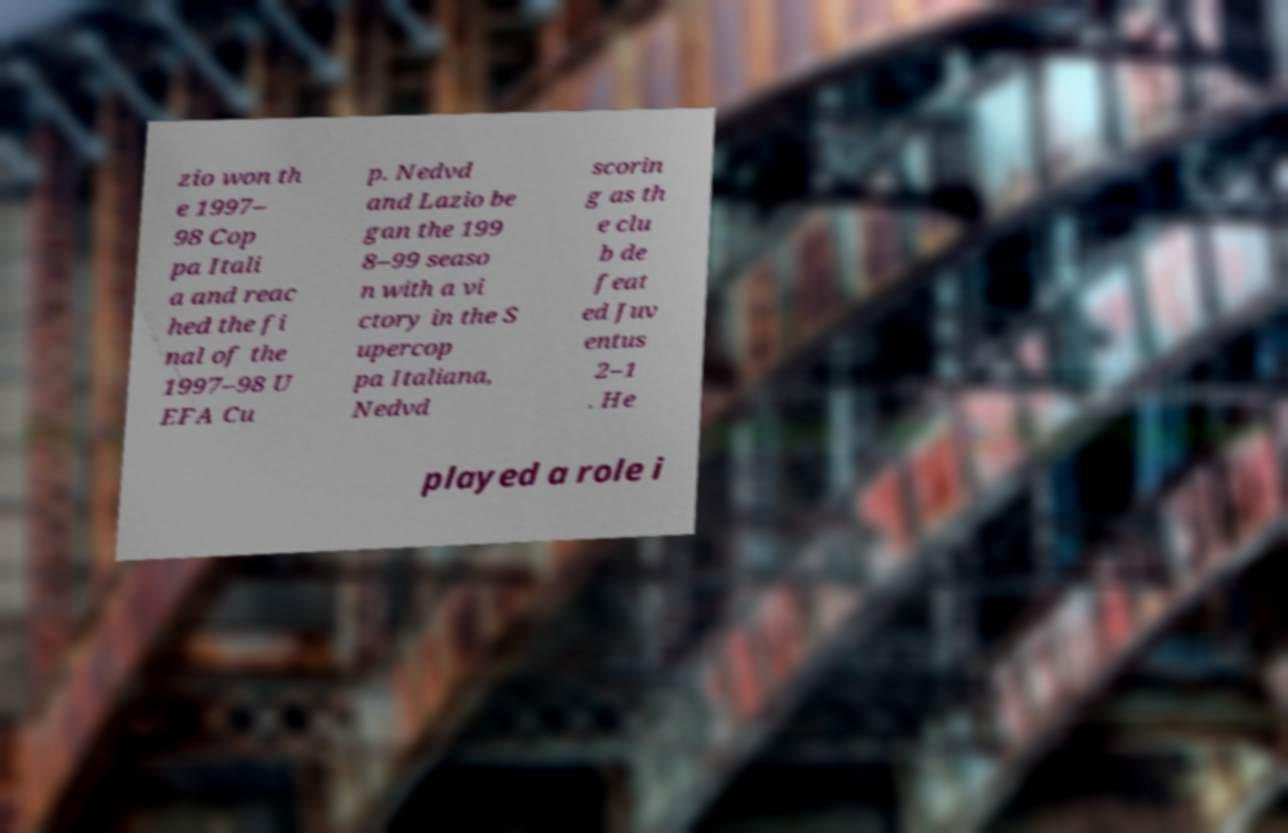There's text embedded in this image that I need extracted. Can you transcribe it verbatim? zio won th e 1997– 98 Cop pa Itali a and reac hed the fi nal of the 1997–98 U EFA Cu p. Nedvd and Lazio be gan the 199 8–99 seaso n with a vi ctory in the S upercop pa Italiana, Nedvd scorin g as th e clu b de feat ed Juv entus 2–1 . He played a role i 